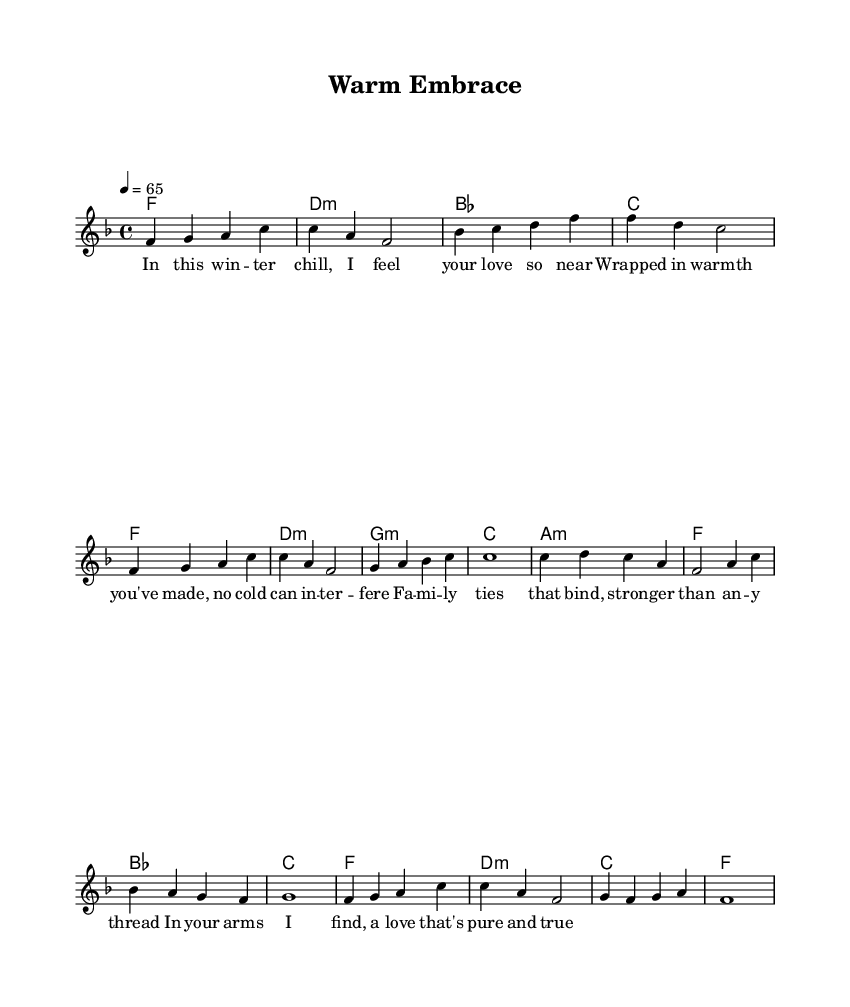What is the key signature of this music? The key signature is F major, which has one flat (B flat). This can be identified at the beginning of the staff right after the clef symbol.
Answer: F major What is the time signature of the piece? The time signature is 4/4, which indicates there are four beats in each measure, and a quarter note receives one beat. This is shown at the beginning of the score next to the key signature.
Answer: 4/4 What is the tempo marking for this music? The tempo marking is quarter note equals 65, which is indicated at the start of the score. This tells the performer to play at a moderate pace.
Answer: 65 What is the style of this piece? The style is Rhythm and Blues, which can be inferred from the use of soulful melodies and lyrics centered around emotional themes like family and love. This is characteristic of the genre.
Answer: Rhythm and Blues How many measures are there in the melody? There are sixteen measures in the melody. By counting the vertical bars (bar lines) on the staff, we can determine the number of separate phrases.
Answer: Sixteen What do the lyrics focus on in this song? The lyrics focus on family love and togetherness, emphasizing warmth and emotional connections during winter. Analyzing the text set to the melody reveals these themes.
Answer: Family love and togetherness 